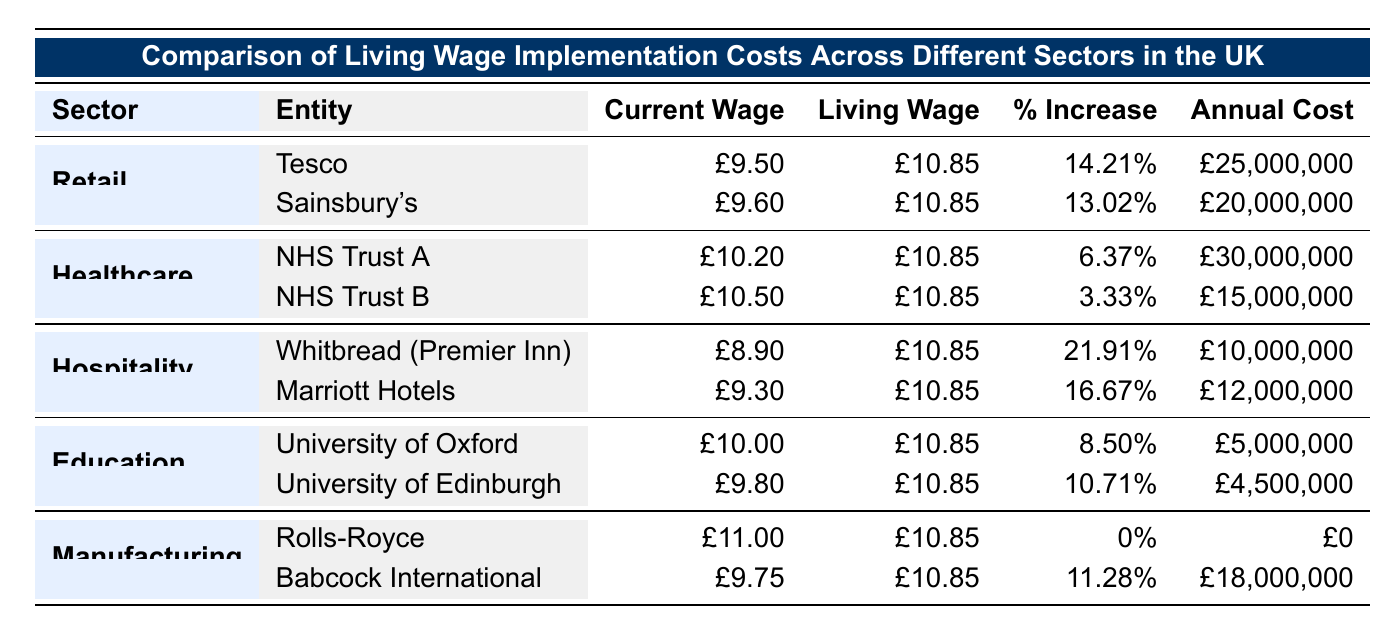What is the total annual cost increase for the Retail sector? To find the total annual cost increase for the Retail sector, we need to add the total cost increase for Tesco and Sainsbury's. Tesco's cost increase is £25,000,000 and Sainsbury's is £20,000,000. Thus, the total is £25,000,000 + £20,000,000 = £45,000,000.
Answer: £45,000,000 Which sector has the highest percentage increase in wages? By reviewing the percentage increase values in the table, we can determine that the Hospitality sector has the highest percentage increase. Specifically, Whitbread has a percentage increase of 21.91%, which is greater than any other sector.
Answer: Hospitality sector Is the current average wage for Rolls-Royce higher than the Living Wage? The current average wage for Rolls-Royce is £11.00, which is higher than the Living Wage of £10.85. This means that they do not need to implement a wage increase according to the Living Wage standards.
Answer: Yes What is the average percentage increase across all sectors? The percentage increases are: Retail (14.21%, 13.02%), Healthcare (6.37%, 3.33%), Hospitality (21.91%, 16.67%), Education (8.50%, 10.71%), and Manufacturing (0%, 11.28%). Adding these gives a total of 14.21 + 13.02 + 6.37 + 3.33 + 21.91 + 16.67 + 8.50 + 10.71 + 0 + 11.28 =  95.00%. Since there are 10 entries, we calculate the average: 95.00 / 10 = 9.50%.
Answer: 9.5% Does NHS Trust A have a higher total cost increase per annum than NHS Trust B? NHS Trust A has a total annual cost increase of £30,000,000 while NHS Trust B has £15,000,000. Since £30,000,000 is greater than £15,000,000, NHS Trust A does have a higher cost increase.
Answer: Yes 